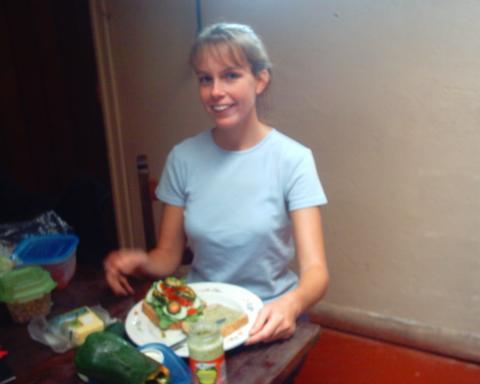What type of sandwich is on the plate?
Concise answer only. Vegetable. What color is the women's shirt?
Short answer required. Blue. Is there movement in the photo?
Short answer required. Yes. 